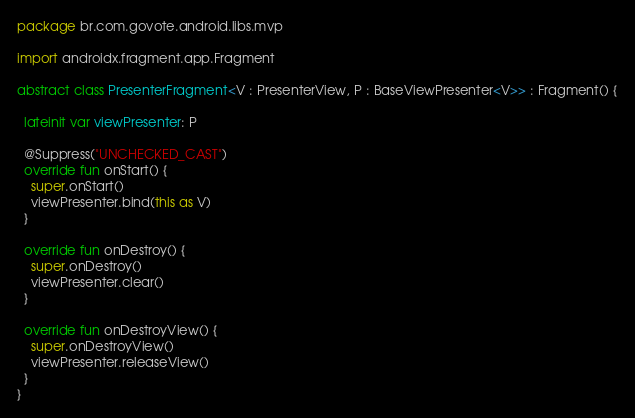<code> <loc_0><loc_0><loc_500><loc_500><_Kotlin_>package br.com.govote.android.libs.mvp

import androidx.fragment.app.Fragment

abstract class PresenterFragment<V : PresenterView, P : BaseViewPresenter<V>> : Fragment() {

  lateinit var viewPresenter: P

  @Suppress("UNCHECKED_CAST")
  override fun onStart() {
    super.onStart()
    viewPresenter.bind(this as V)
  }

  override fun onDestroy() {
    super.onDestroy()
    viewPresenter.clear()
  }

  override fun onDestroyView() {
    super.onDestroyView()
    viewPresenter.releaseView()
  }
}
</code> 